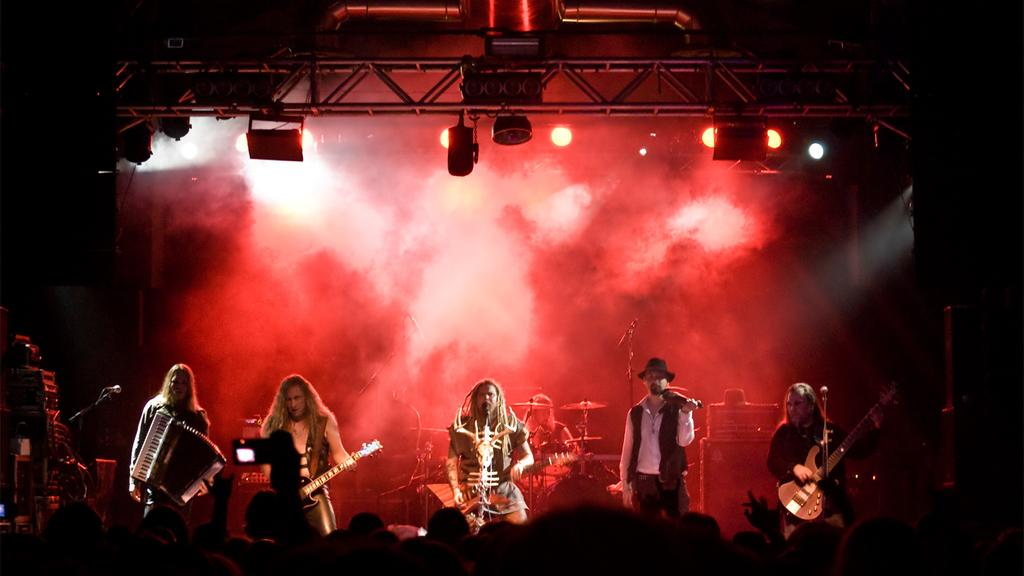What is happening on the stage in the image? There are people on the stage, and they are performing. What are the people on the stage doing? They are playing musical instruments. What can be seen in the background of the image? There are boxes, musical instruments, lights, and poles in the background. Is there any special effect visible in the image? Yes, smoke is visible in the image. What type of love story is being told through the performance in the image? There is no indication of a love story or any narrative in the image; it simply shows people playing musical instruments on a stage. Can you describe the marble flooring in the image? There is no marble flooring present in the image. 